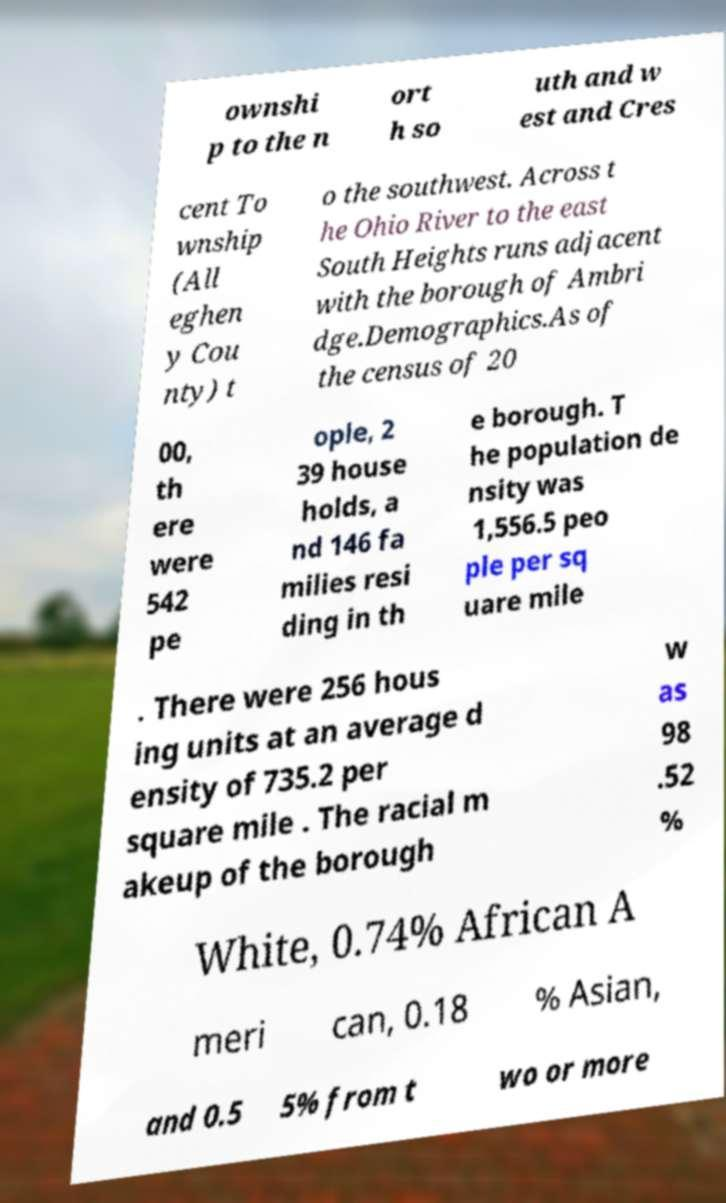I need the written content from this picture converted into text. Can you do that? ownshi p to the n ort h so uth and w est and Cres cent To wnship (All eghen y Cou nty) t o the southwest. Across t he Ohio River to the east South Heights runs adjacent with the borough of Ambri dge.Demographics.As of the census of 20 00, th ere were 542 pe ople, 2 39 house holds, a nd 146 fa milies resi ding in th e borough. T he population de nsity was 1,556.5 peo ple per sq uare mile . There were 256 hous ing units at an average d ensity of 735.2 per square mile . The racial m akeup of the borough w as 98 .52 % White, 0.74% African A meri can, 0.18 % Asian, and 0.5 5% from t wo or more 